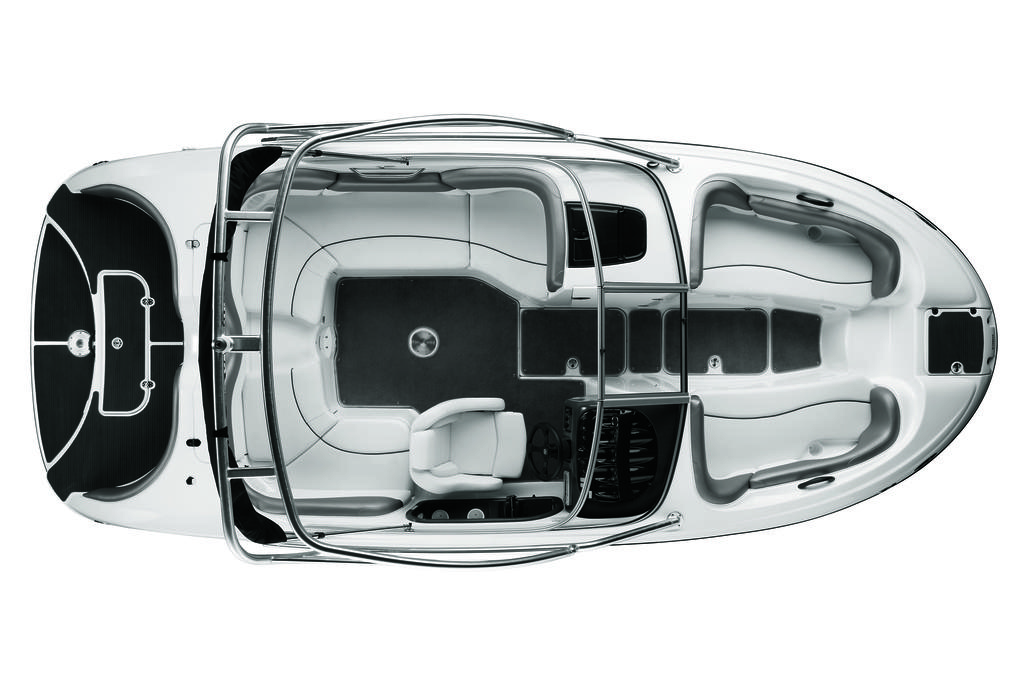What is the main subject of the image? The main subject of the image is a model of a car. What type of square canvas can be seen in the image? There is no square canvas present in the image; it features a model of a car. How many ears can be seen on the car in the image? Cars do not have ears, so this question is not applicable to the image. 